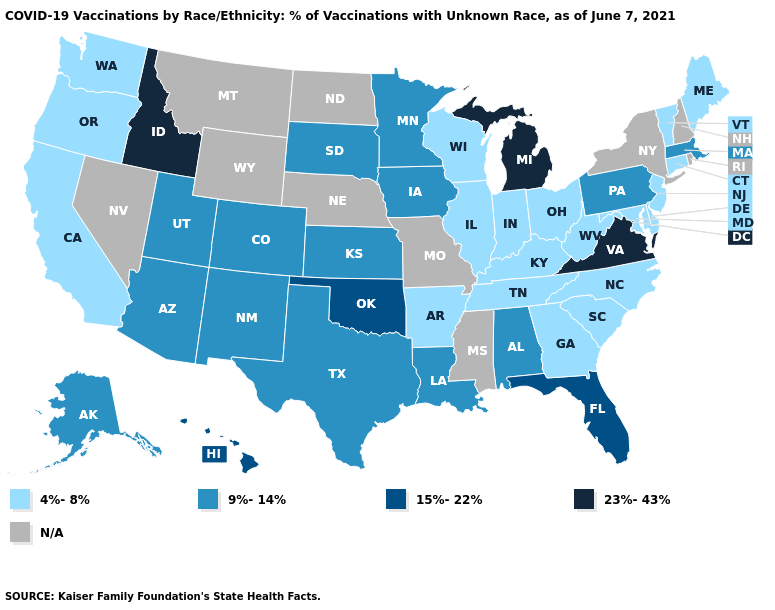What is the value of New Jersey?
Quick response, please. 4%-8%. What is the value of Virginia?
Answer briefly. 23%-43%. What is the value of Michigan?
Give a very brief answer. 23%-43%. Which states have the highest value in the USA?
Quick response, please. Idaho, Michigan, Virginia. Does Wisconsin have the lowest value in the USA?
Answer briefly. Yes. What is the highest value in the West ?
Keep it brief. 23%-43%. What is the value of Maine?
Quick response, please. 4%-8%. Does Michigan have the highest value in the USA?
Give a very brief answer. Yes. Name the states that have a value in the range N/A?
Answer briefly. Mississippi, Missouri, Montana, Nebraska, Nevada, New Hampshire, New York, North Dakota, Rhode Island, Wyoming. Name the states that have a value in the range 9%-14%?
Answer briefly. Alabama, Alaska, Arizona, Colorado, Iowa, Kansas, Louisiana, Massachusetts, Minnesota, New Mexico, Pennsylvania, South Dakota, Texas, Utah. What is the highest value in the USA?
Short answer required. 23%-43%. What is the value of Nevada?
Keep it brief. N/A. What is the highest value in states that border Arizona?
Write a very short answer. 9%-14%. Name the states that have a value in the range 4%-8%?
Give a very brief answer. Arkansas, California, Connecticut, Delaware, Georgia, Illinois, Indiana, Kentucky, Maine, Maryland, New Jersey, North Carolina, Ohio, Oregon, South Carolina, Tennessee, Vermont, Washington, West Virginia, Wisconsin. 